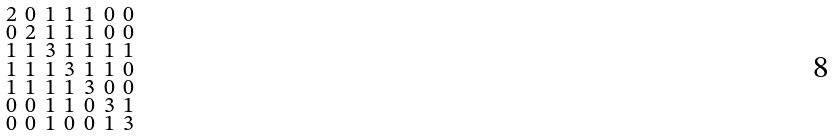Convert formula to latex. <formula><loc_0><loc_0><loc_500><loc_500>\begin{smallmatrix} 2 & 0 & 1 & 1 & 1 & 0 & 0 \\ 0 & 2 & 1 & 1 & 1 & 0 & 0 \\ 1 & 1 & 3 & 1 & 1 & 1 & 1 \\ 1 & 1 & 1 & 3 & 1 & 1 & 0 \\ 1 & 1 & 1 & 1 & 3 & 0 & 0 \\ 0 & 0 & 1 & 1 & 0 & 3 & 1 \\ 0 & 0 & 1 & 0 & 0 & 1 & 3 \end{smallmatrix}</formula> 